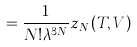<formula> <loc_0><loc_0><loc_500><loc_500>= \frac { 1 } { N ! \lambda ^ { 3 N } } z _ { N } ( T , V )</formula> 